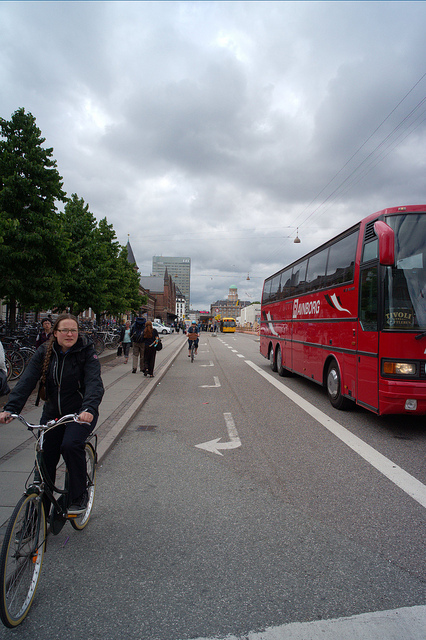<image>What collection is this image from? I don't know what collection the image is from. It can be from 'bus', 'vacation', 'street cam' or 'google maps'. What collection is this image from? I don't know what collection this image is from. 